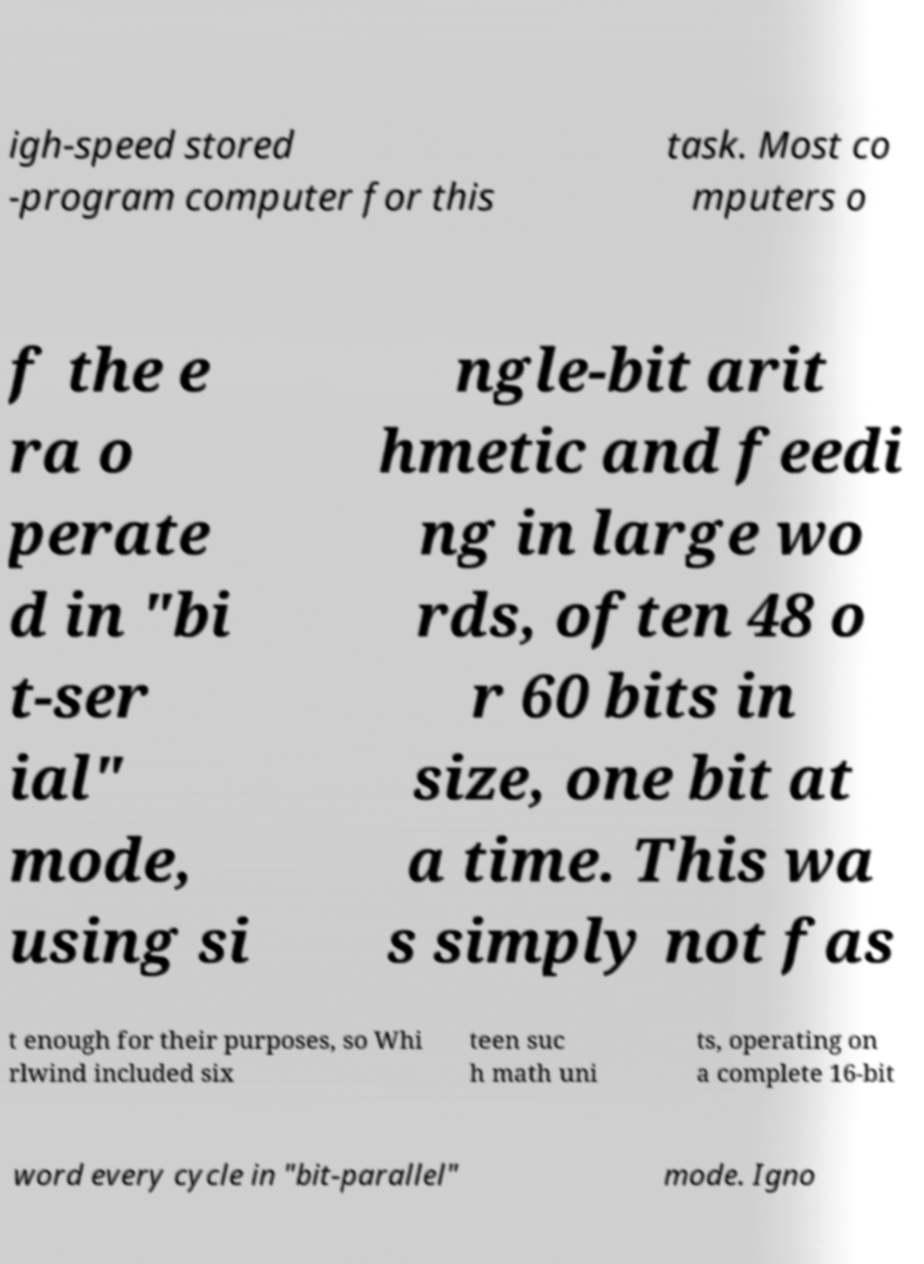Please identify and transcribe the text found in this image. igh-speed stored -program computer for this task. Most co mputers o f the e ra o perate d in "bi t-ser ial" mode, using si ngle-bit arit hmetic and feedi ng in large wo rds, often 48 o r 60 bits in size, one bit at a time. This wa s simply not fas t enough for their purposes, so Whi rlwind included six teen suc h math uni ts, operating on a complete 16-bit word every cycle in "bit-parallel" mode. Igno 